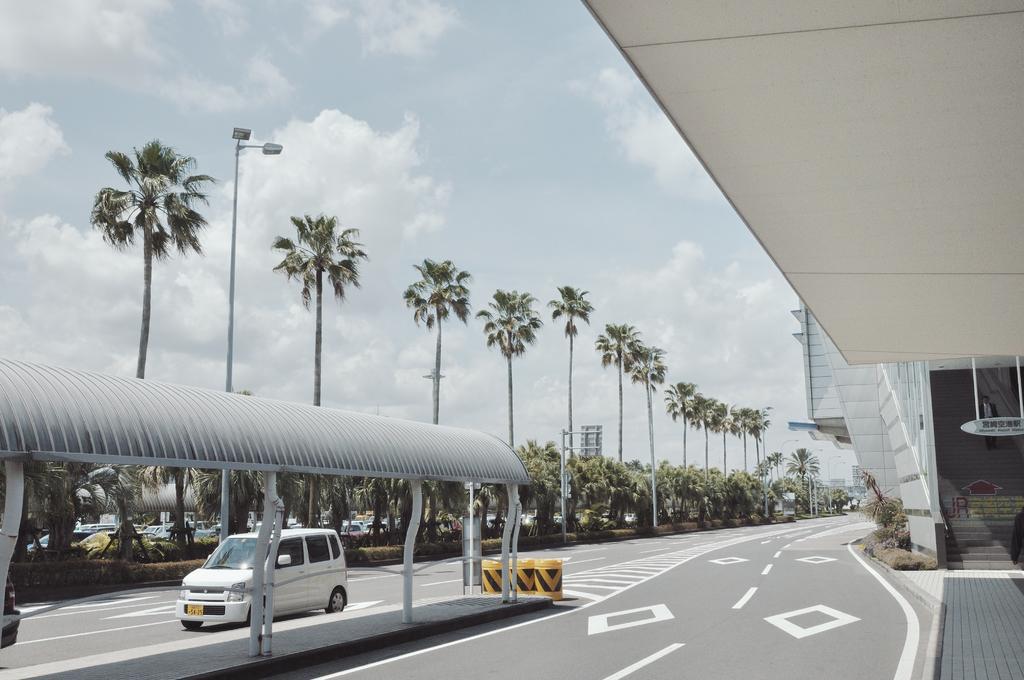Could you give a brief overview of what you see in this image? In this picture I can see vehicles on the road, there is a shed, plants, trees, lights, poles, buildings, and in the background there is sky. 